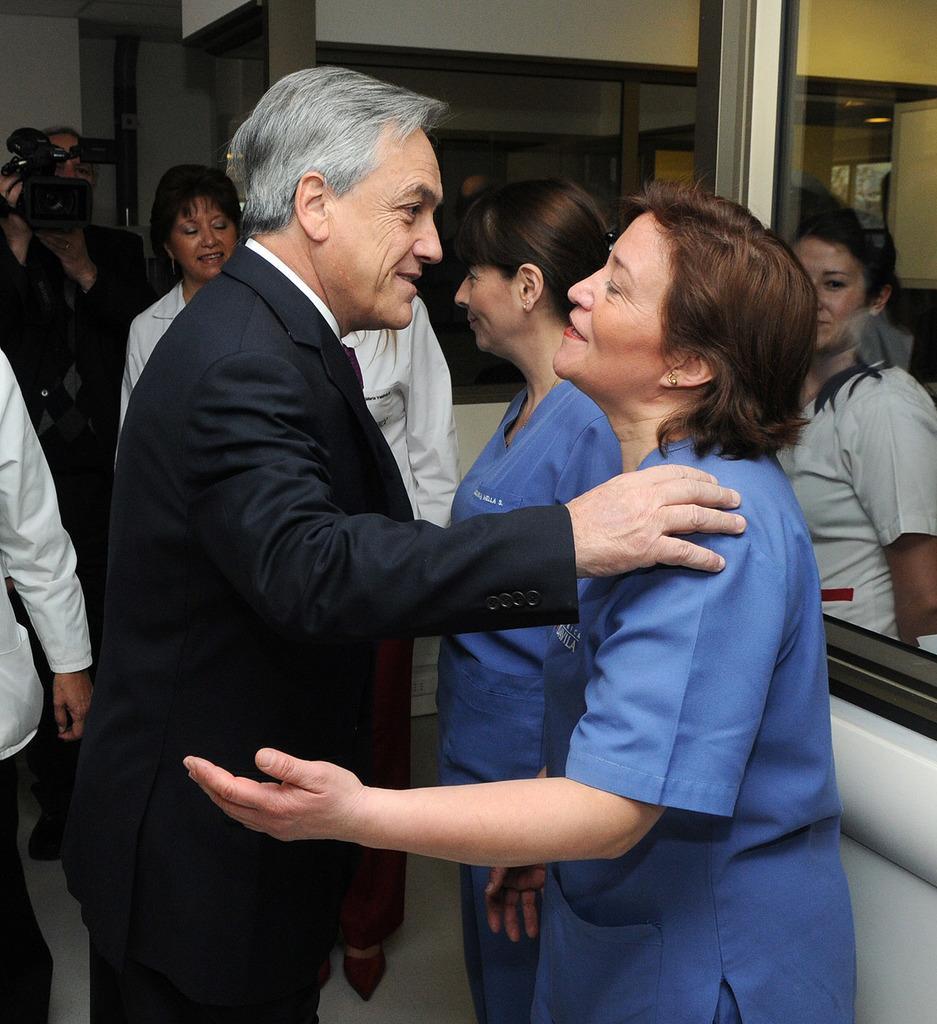Please provide a concise description of this image. In this image I can see number of people are standing and I can see most of them are wearing white colour dress. I can also see two persons are wearing blue colour and rest all are wearing black colour of dress. On the top left side of the image I can see one person is holding a camera. 